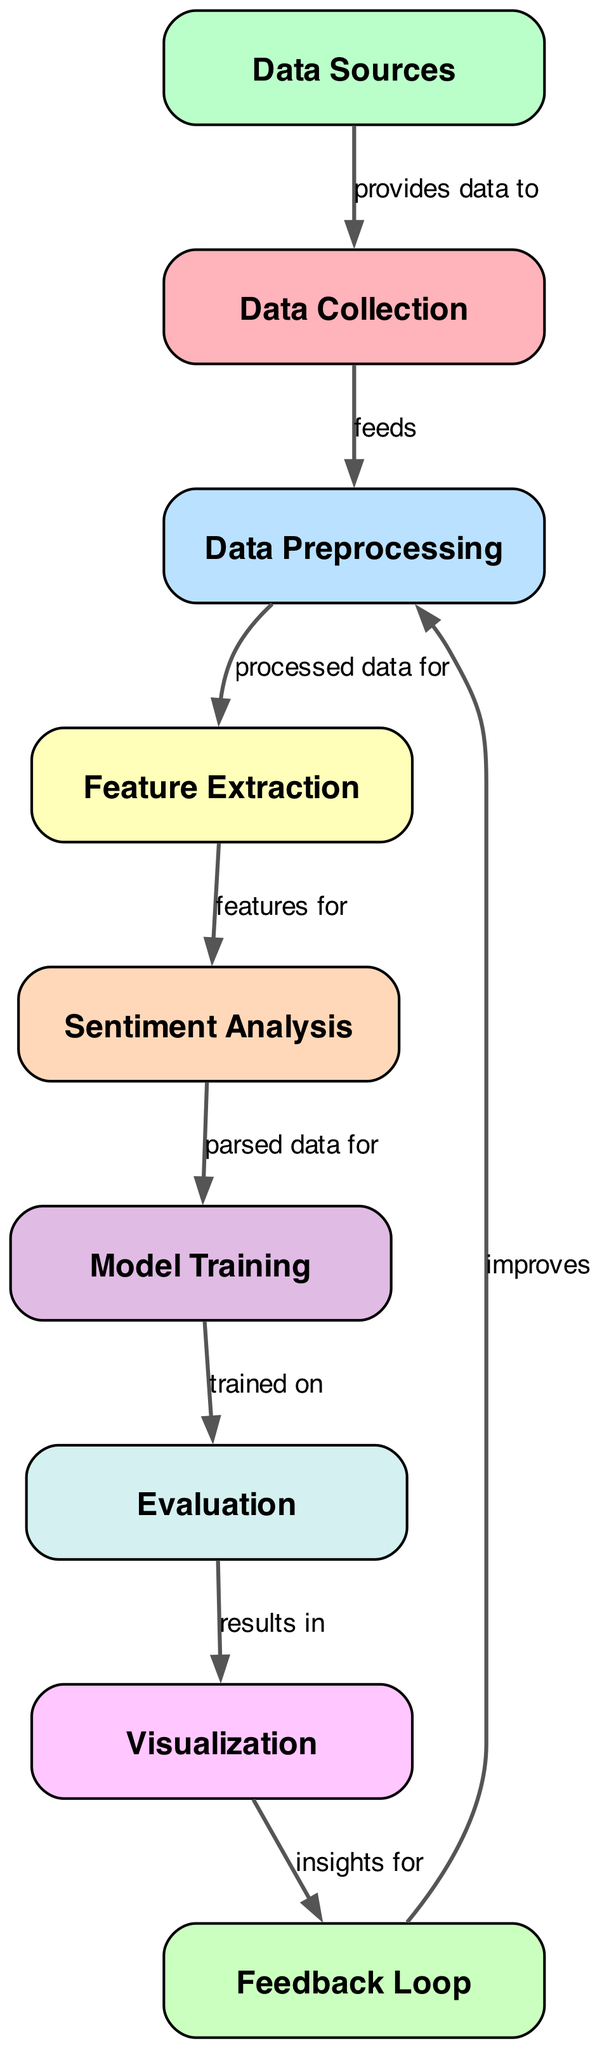What are the data sources used? The diagram specifies three data sources: Spotify API, Musixmatch, and Genius that contribute data to the data collection node.
Answer: Spotify API, Musixmatch, Genius How many nodes are present in the diagram? A count of the nodes listed in the diagram reveals there are ten key elements which are all related to the sentiment analysis process.
Answer: Ten What node feeds into the data preprocessing? The data collection node feeds processed data into the data preprocessing node, as indicated by the directed arrow connecting them.
Answer: Data collection What type of models are used in model training? The model training node mentions "Supervised learning" and specifies "classification models (SVM, Random Forest)" as the methods used for training.
Answer: Classification models (SVM, Random Forest) What insights do visualization provide for? The visualization node provides insights for the feedback loop, indicating the flow of information from results of sentiments to improve the preceding stage.
Answer: Feedback loop How does the feedback loop improve the diagram process? The feedback loop improves the process by allowing manual review and retraining of the model based on insights from the visualization node, creating a cycle of continuous improvement.
Answer: Improves data preprocessing What are the evaluation metrics mentioned? The evaluation node indicates three metrics used for measuring performance: Accuracy, F1 Score, and Confusion Matrix.
Answer: Accuracy, F1 Score, Confusion Matrix Which node receives features for sentiment analysis? The sentiment analysis node receives features provided by the feature extraction node, showing how data transformation leads to sentiment evaluation.
Answer: Feature extraction What is the primary goal of the sentiment analysis node? The sentiment analysis node's primary goal is to parse data using various sentiment analysis tools like VADER, TextBlob, and BERT.
Answer: Parse data 